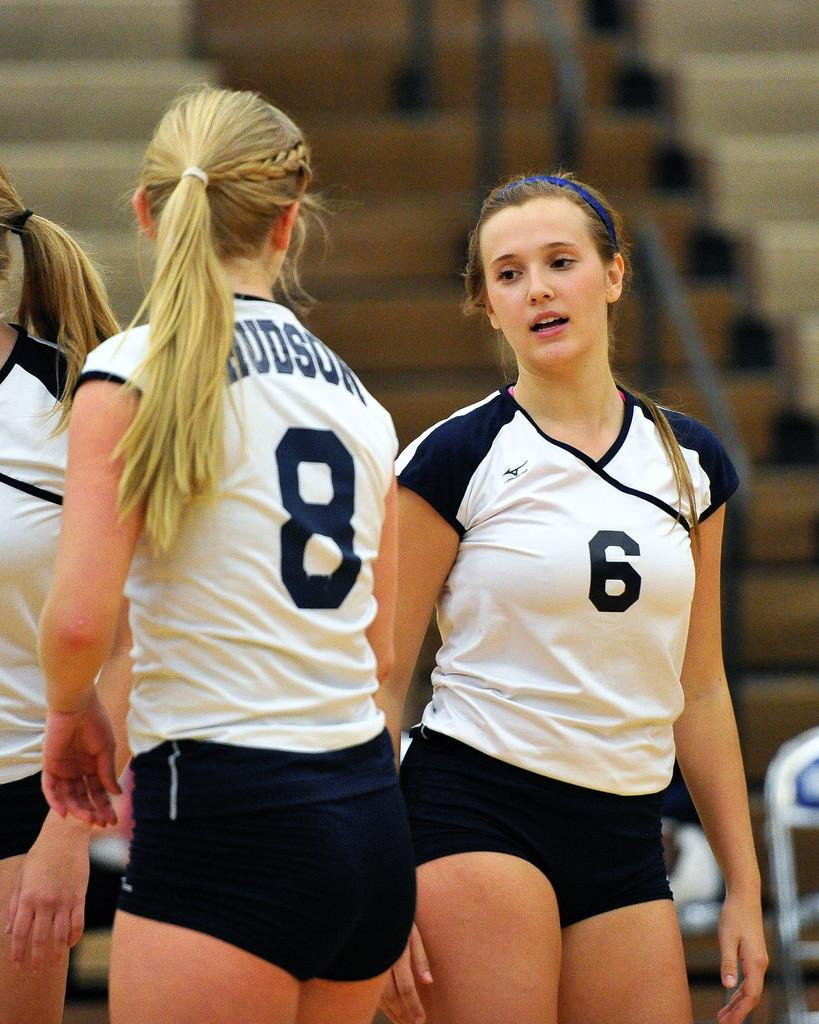<image>
Share a concise interpretation of the image provided. Two athletic women, one named Hudson, wearing tight dark shorts and white jerseys looking at each other 